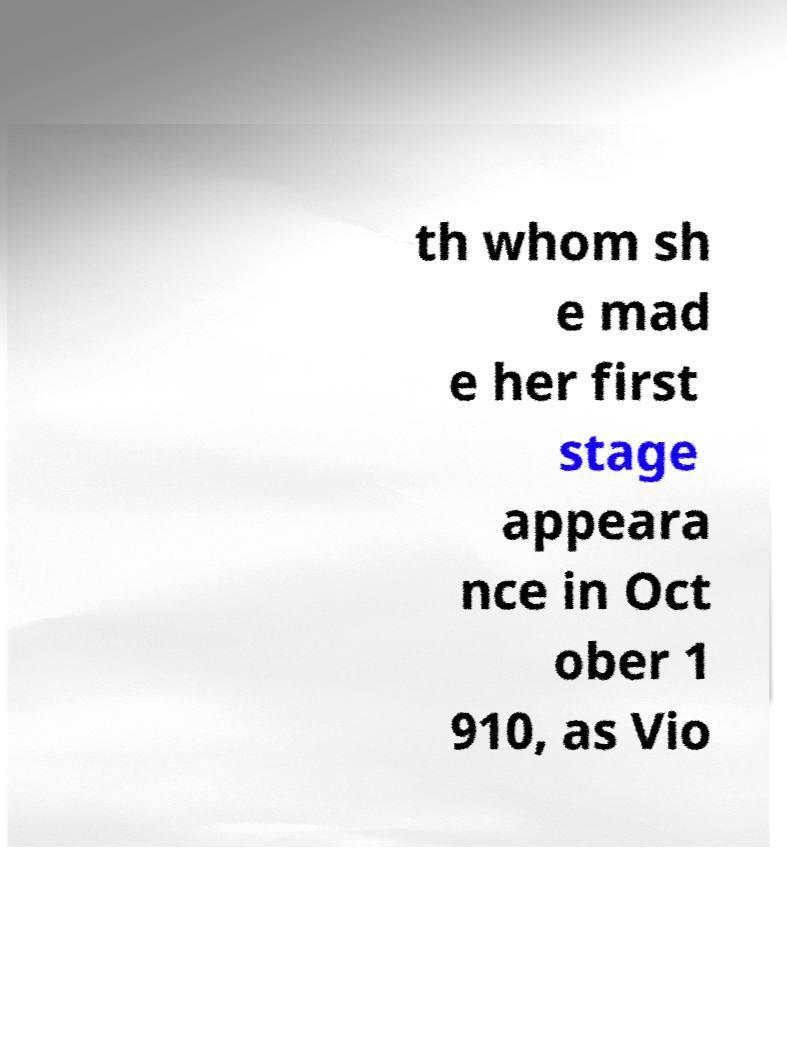Please identify and transcribe the text found in this image. th whom sh e mad e her first stage appeara nce in Oct ober 1 910, as Vio 